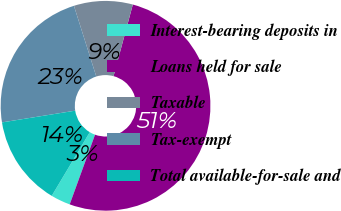Convert chart. <chart><loc_0><loc_0><loc_500><loc_500><pie_chart><fcel>Interest-bearing deposits in<fcel>Loans held for sale<fcel>Taxable<fcel>Tax-exempt<fcel>Total available-for-sale and<nl><fcel>3.02%<fcel>51.36%<fcel>9.06%<fcel>22.66%<fcel>13.9%<nl></chart> 